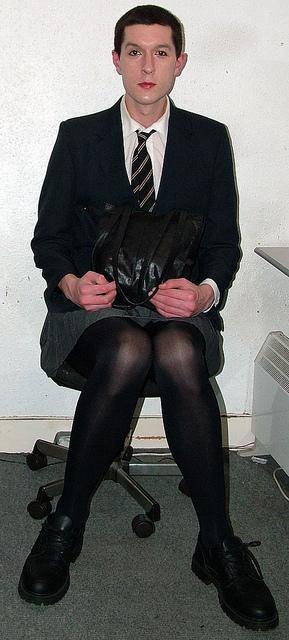What is the term for this person?
Answer briefly. Transvestite. Is he wearing black stockings?
Short answer required. Yes. What color is the man's jacket?
Write a very short answer. Black. 